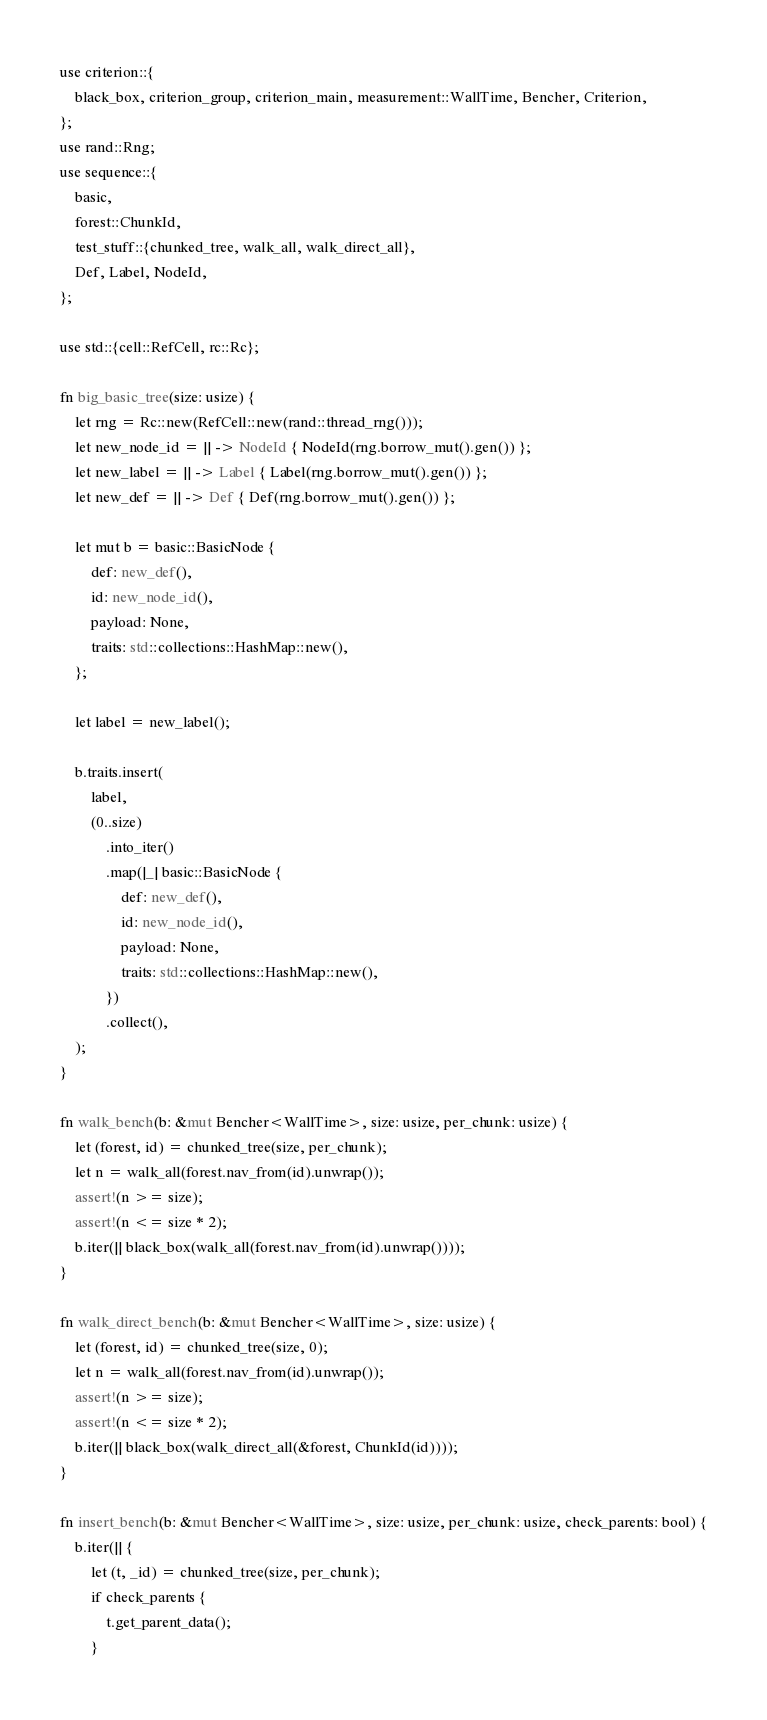<code> <loc_0><loc_0><loc_500><loc_500><_Rust_>use criterion::{
    black_box, criterion_group, criterion_main, measurement::WallTime, Bencher, Criterion,
};
use rand::Rng;
use sequence::{
    basic,
    forest::ChunkId,
    test_stuff::{chunked_tree, walk_all, walk_direct_all},
    Def, Label, NodeId,
};

use std::{cell::RefCell, rc::Rc};

fn big_basic_tree(size: usize) {
    let rng = Rc::new(RefCell::new(rand::thread_rng()));
    let new_node_id = || -> NodeId { NodeId(rng.borrow_mut().gen()) };
    let new_label = || -> Label { Label(rng.borrow_mut().gen()) };
    let new_def = || -> Def { Def(rng.borrow_mut().gen()) };

    let mut b = basic::BasicNode {
        def: new_def(),
        id: new_node_id(),
        payload: None,
        traits: std::collections::HashMap::new(),
    };

    let label = new_label();

    b.traits.insert(
        label,
        (0..size)
            .into_iter()
            .map(|_| basic::BasicNode {
                def: new_def(),
                id: new_node_id(),
                payload: None,
                traits: std::collections::HashMap::new(),
            })
            .collect(),
    );
}

fn walk_bench(b: &mut Bencher<WallTime>, size: usize, per_chunk: usize) {
    let (forest, id) = chunked_tree(size, per_chunk);
    let n = walk_all(forest.nav_from(id).unwrap());
    assert!(n >= size);
    assert!(n <= size * 2);
    b.iter(|| black_box(walk_all(forest.nav_from(id).unwrap())));
}

fn walk_direct_bench(b: &mut Bencher<WallTime>, size: usize) {
    let (forest, id) = chunked_tree(size, 0);
    let n = walk_all(forest.nav_from(id).unwrap());
    assert!(n >= size);
    assert!(n <= size * 2);
    b.iter(|| black_box(walk_direct_all(&forest, ChunkId(id))));
}

fn insert_bench(b: &mut Bencher<WallTime>, size: usize, per_chunk: usize, check_parents: bool) {
    b.iter(|| {
        let (t, _id) = chunked_tree(size, per_chunk);
        if check_parents {
            t.get_parent_data();
        }</code> 